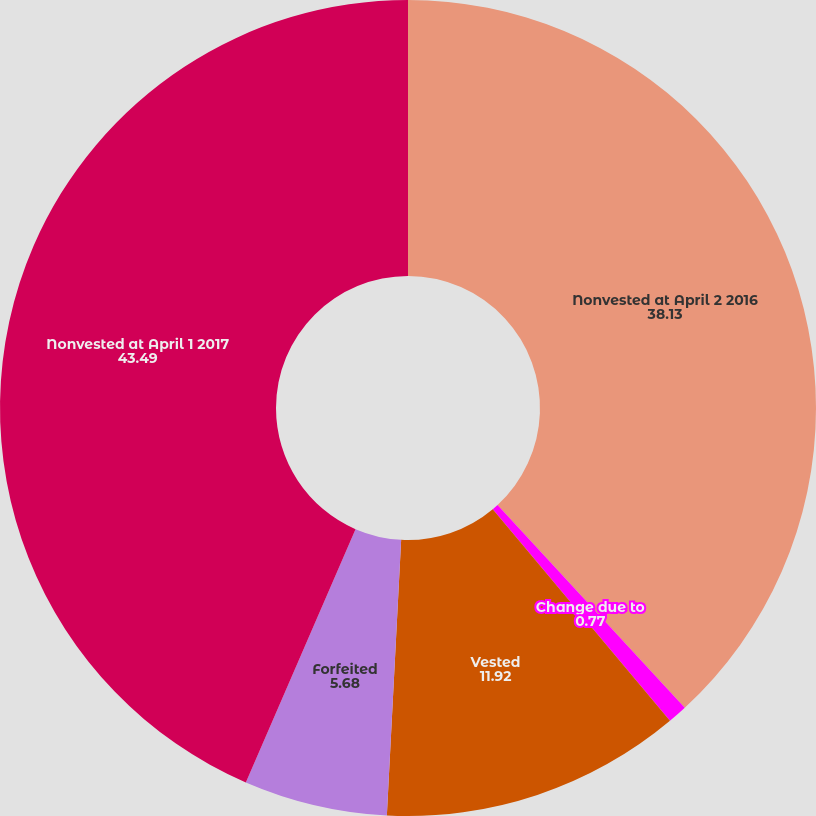Convert chart to OTSL. <chart><loc_0><loc_0><loc_500><loc_500><pie_chart><fcel>Nonvested at April 2 2016<fcel>Change due to<fcel>Vested<fcel>Forfeited<fcel>Nonvested at April 1 2017<nl><fcel>38.13%<fcel>0.77%<fcel>11.92%<fcel>5.68%<fcel>43.49%<nl></chart> 